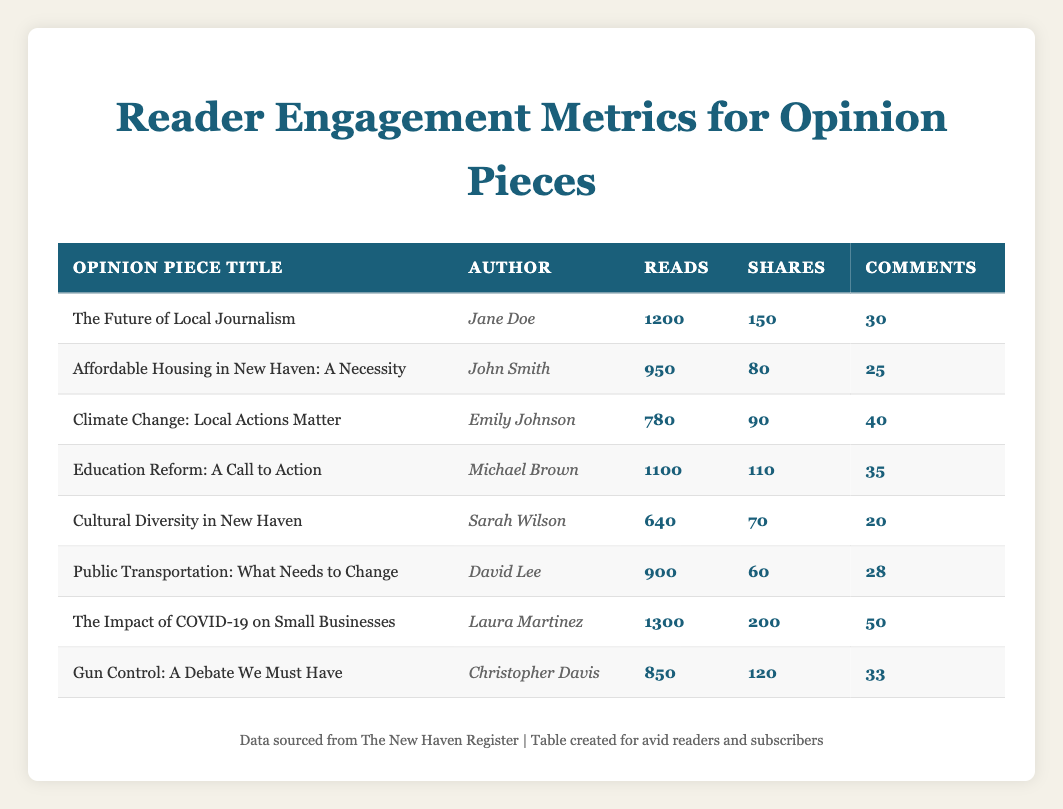What is the title of the opinion piece with the most reads? To find this, we examine the "Reads" column and identify the highest number. The highest value is 1300, which corresponds to the opinion piece titled "The Impact of COVID-19 on Small Businesses."
Answer: The Impact of COVID-19 on Small Businesses How many comments did the opinion piece "Education Reform: A Call to Action" receive? We look up "Education Reform: A Call to Action" in the table and check the "Comments" column in the same row. It shows 35 comments.
Answer: 35 Which author wrote the opinion piece with the least shares? We look through the "Shares" column to find the minimum value. The least number of shares is 60, which corresponds to David Lee, the author of "Public Transportation: What Needs to Change."
Answer: David Lee What is the total number of reads for all opinion pieces? We sum the "Reads" column values: 1200 + 950 + 780 + 1100 + 640 + 900 + 1300 + 850 = 5820.
Answer: 5820 Is there an opinion piece authored by Sarah Wilson that has more than 700 reads? We check the entry for Sarah Wilson and find her opinion piece "Cultural Diversity in New Haven," which has 640 reads, not exceeding 700.
Answer: No What is the average number of shares for all pieces? First, we calculate the total shares: 150 + 80 + 90 + 110 + 70 + 60 + 200 + 120 = 920. There are 8 pieces, so we divide 920 by 8: 920 / 8 = 115.
Answer: 115 Which opinion piece received the most comments, and how many did it get? We scan the "Comments" column for the highest value. The highest value is 50, corresponding to "The Impact of COVID-19 on Small Businesses."
Answer: The Impact of COVID-19 on Small Businesses, 50 Are there any opinion pieces with more reads than 1000? We review the "Reads" column looking for numbers greater than 1000. The pieces titled "The Impact of COVID-19 on Small Businesses" and "The Future of Local Journalism" have more than 1000 reads.
Answer: Yes How many more reads did "The Future of Local Journalism" have compared to "Gun Control: A Debate We Must Have"? We subtract the reads of "Gun Control: A Debate We Must Have" (850) from "The Future of Local Journalism" (1200): 1200 - 850 = 350.
Answer: 350 